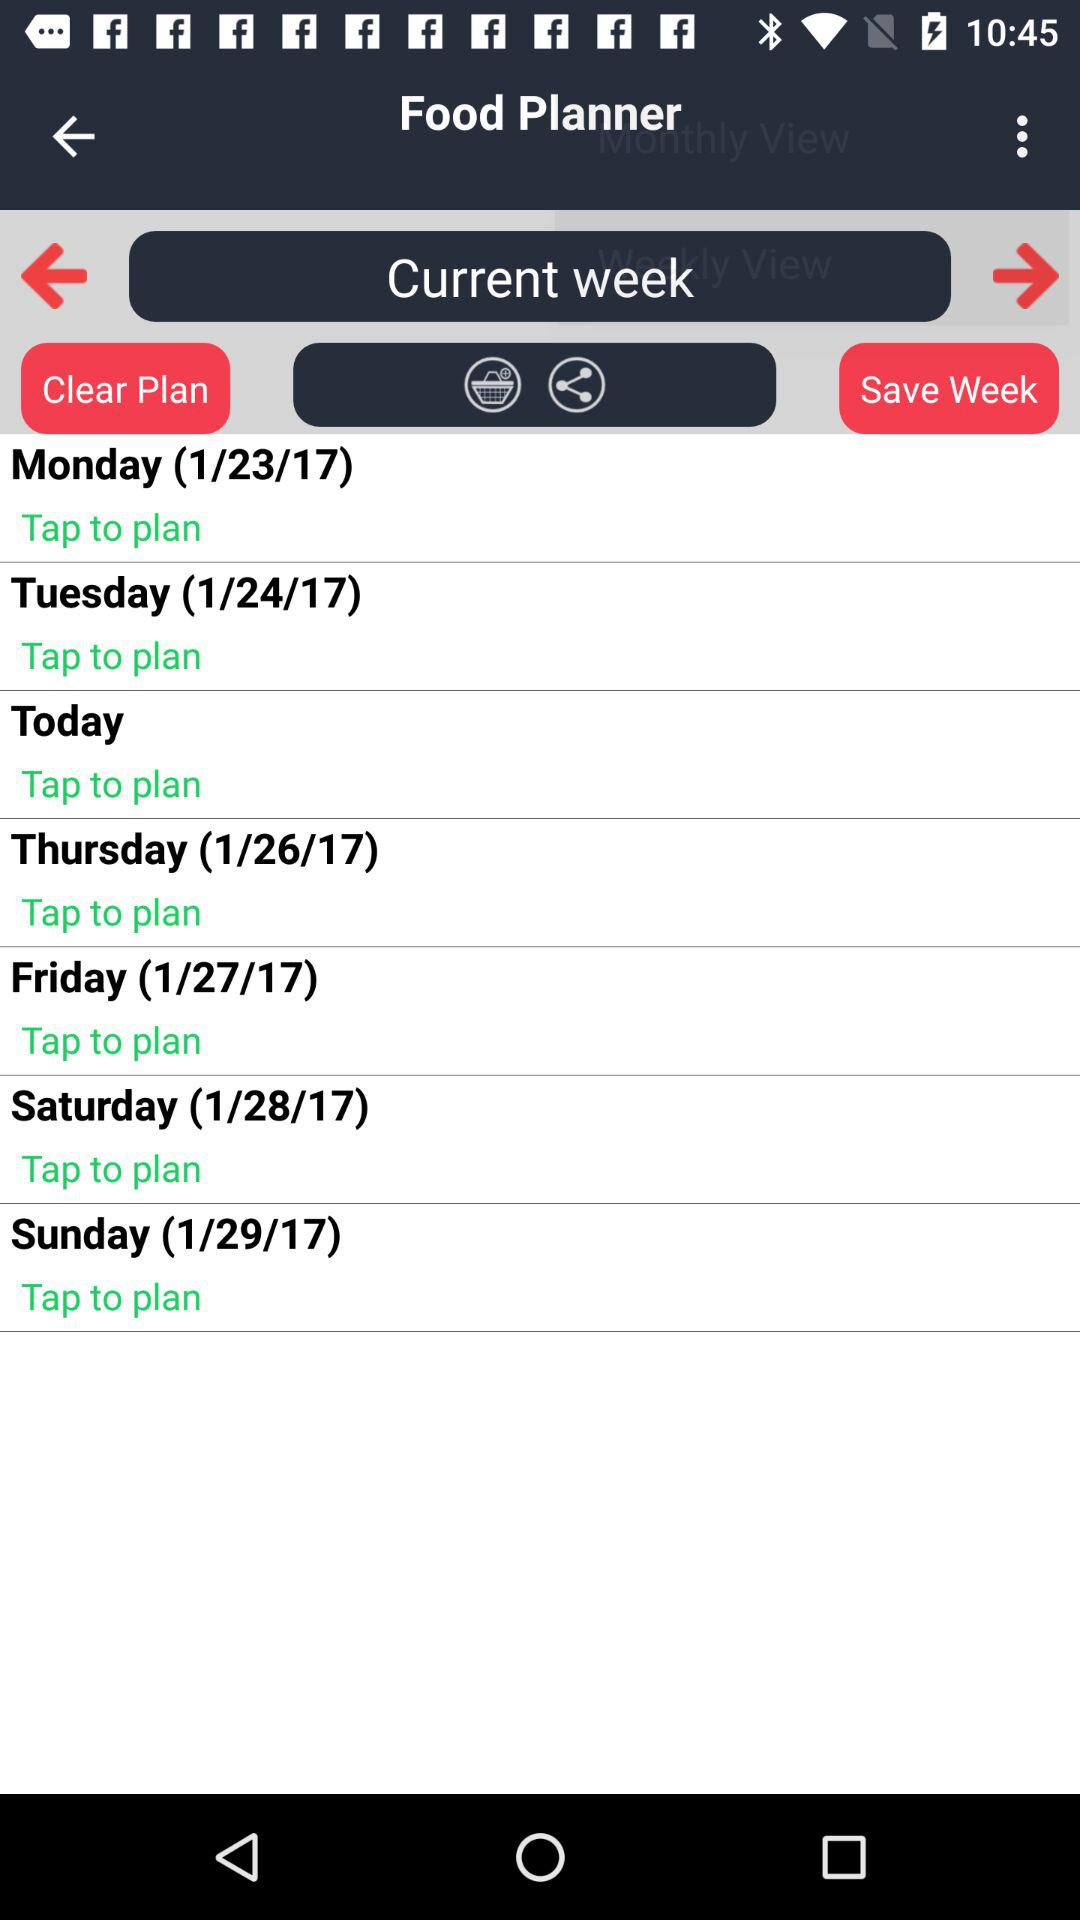What's the date on Friday? The date on Friday is January 27, 2017. 